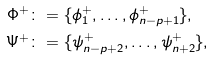<formula> <loc_0><loc_0><loc_500><loc_500>\Phi ^ { + } \colon & = \{ \phi ^ { + } _ { 1 } , \dots , \phi ^ { + } _ { n - p + 1 } \} , \\ \Psi ^ { + } \colon & = \{ \psi _ { n - p + 2 } ^ { + } , \dots , \psi _ { n + 2 } ^ { + } \} ,</formula> 